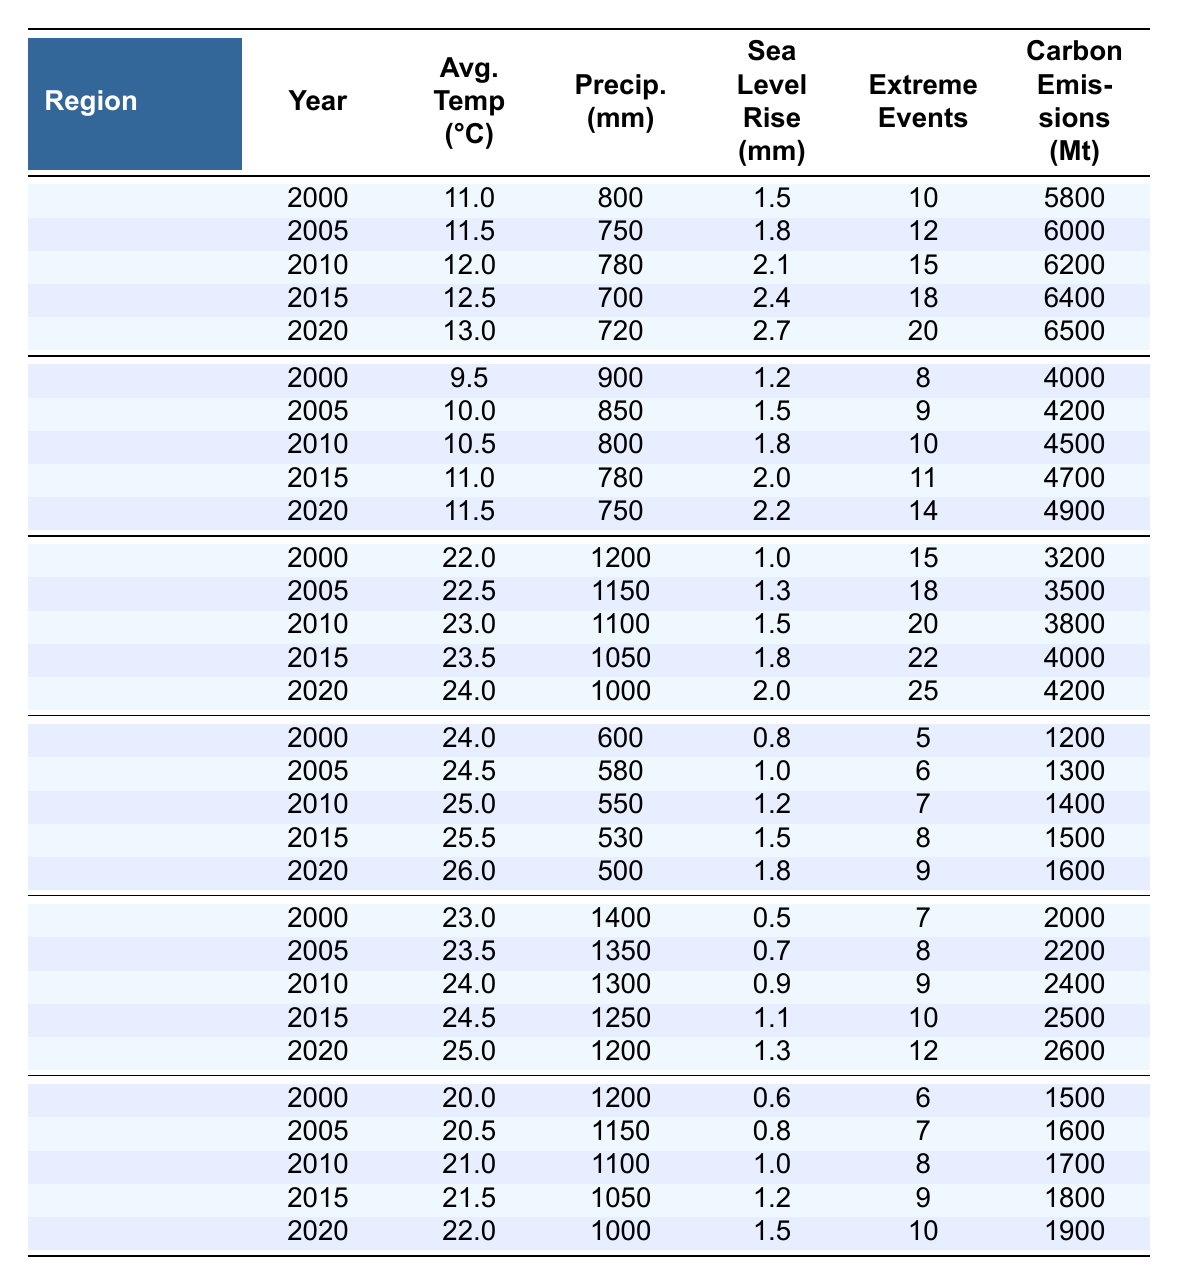What was the average temperature in North America in 2010? The table shows that the average temperature in North America for the year 2010 is 12.0°C.
Answer: 12.0°C Which region had the highest carbon emissions in 2020? According to the table, North America had the highest carbon emissions in 2020 at 6500 Mt.
Answer: North America What was the total precipitation in Africa from 2000 to 2020? Adding the precipitation values from the table for Africa: 600 + 580 + 550 + 530 + 500 = 2860 mm.
Answer: 2860 mm True or False: The average temperature in Europe increased every five years from 2000 to 2020. Checking the values in the table, the average temperature in Europe for each year from 2000 to 2020 shows a consistent increase: 9.5, 10.0, 10.5, 11.0, 11.5°C. Thus, it is true.
Answer: True What is the difference in extreme weather events in Asia between 2000 and 2020? The number of extreme weather events in Asia was 15 in 2000 and increased to 25 in 2020, so the difference is 25 - 15 = 10 events.
Answer: 10 events In which year did Oceania experience the highest average temperature? The table indicates that Oceania had the highest average temperature of 22.0°C in the year 2020.
Answer: 2020 What was the trend in precipitation for South America from 2000 to 2020? The table shows a decrease in precipitation values for South America: 1400, 1350, 1300, 1250, 1200 mm over the years, indicating a downward trend.
Answer: Downward trend Calculate the average sea level rise for Africa from 2000 to 2020. The sea level rise values for Africa are: 0.8, 1.0, 1.2, 1.5, 1.8 mm. The average can be calculated as (0.8 + 1.0 + 1.2 + 1.5 + 1.8) / 5 = 1.46 mm.
Answer: 1.46 mm Did the average temperature in South America exceed 25°C in any year from 2000 to 2020? Looking at the average temperature values for South America, the year 2020 shows an average temperature of 25.0°C, which is the only instance where it reached or exceeded 25°C.
Answer: Yes What was the percentage increase in carbon emissions in North America from 2000 to 2020? The carbon emissions in North America were 5800 Mt in 2000 and 6500 Mt in 2020. To find the percentage increase: ((6500 - 5800) / 5800) * 100 = 12.07%.
Answer: 12.07% 